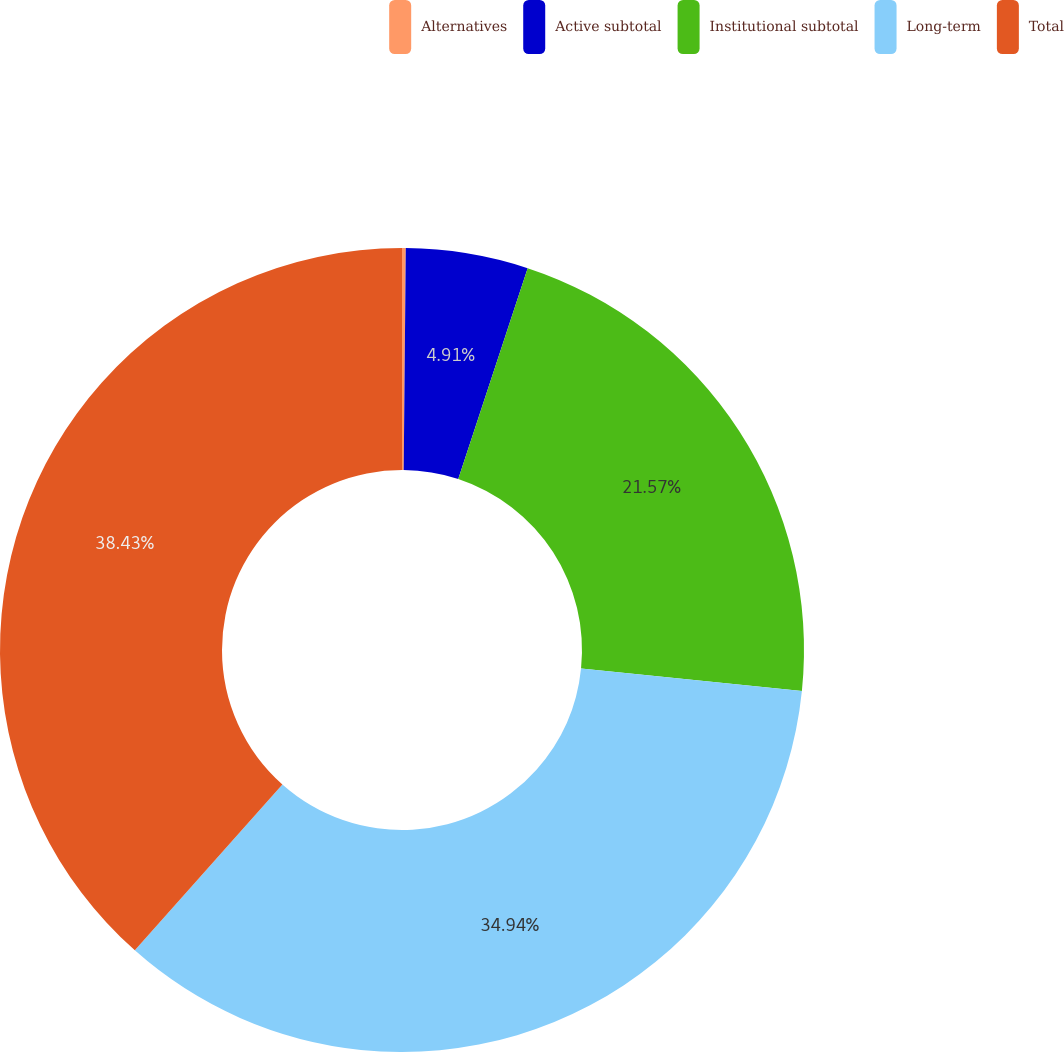Convert chart. <chart><loc_0><loc_0><loc_500><loc_500><pie_chart><fcel>Alternatives<fcel>Active subtotal<fcel>Institutional subtotal<fcel>Long-term<fcel>Total<nl><fcel>0.15%<fcel>4.91%<fcel>21.57%<fcel>34.94%<fcel>38.43%<nl></chart> 